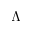Convert formula to latex. <formula><loc_0><loc_0><loc_500><loc_500>{ \Lambda }</formula> 